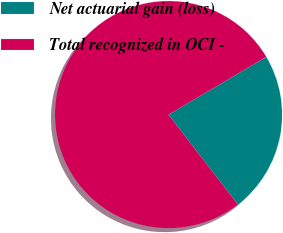Convert chart. <chart><loc_0><loc_0><loc_500><loc_500><pie_chart><fcel>Net actuarial gain (loss)<fcel>Total recognized in OCI -<nl><fcel>23.01%<fcel>76.99%<nl></chart> 